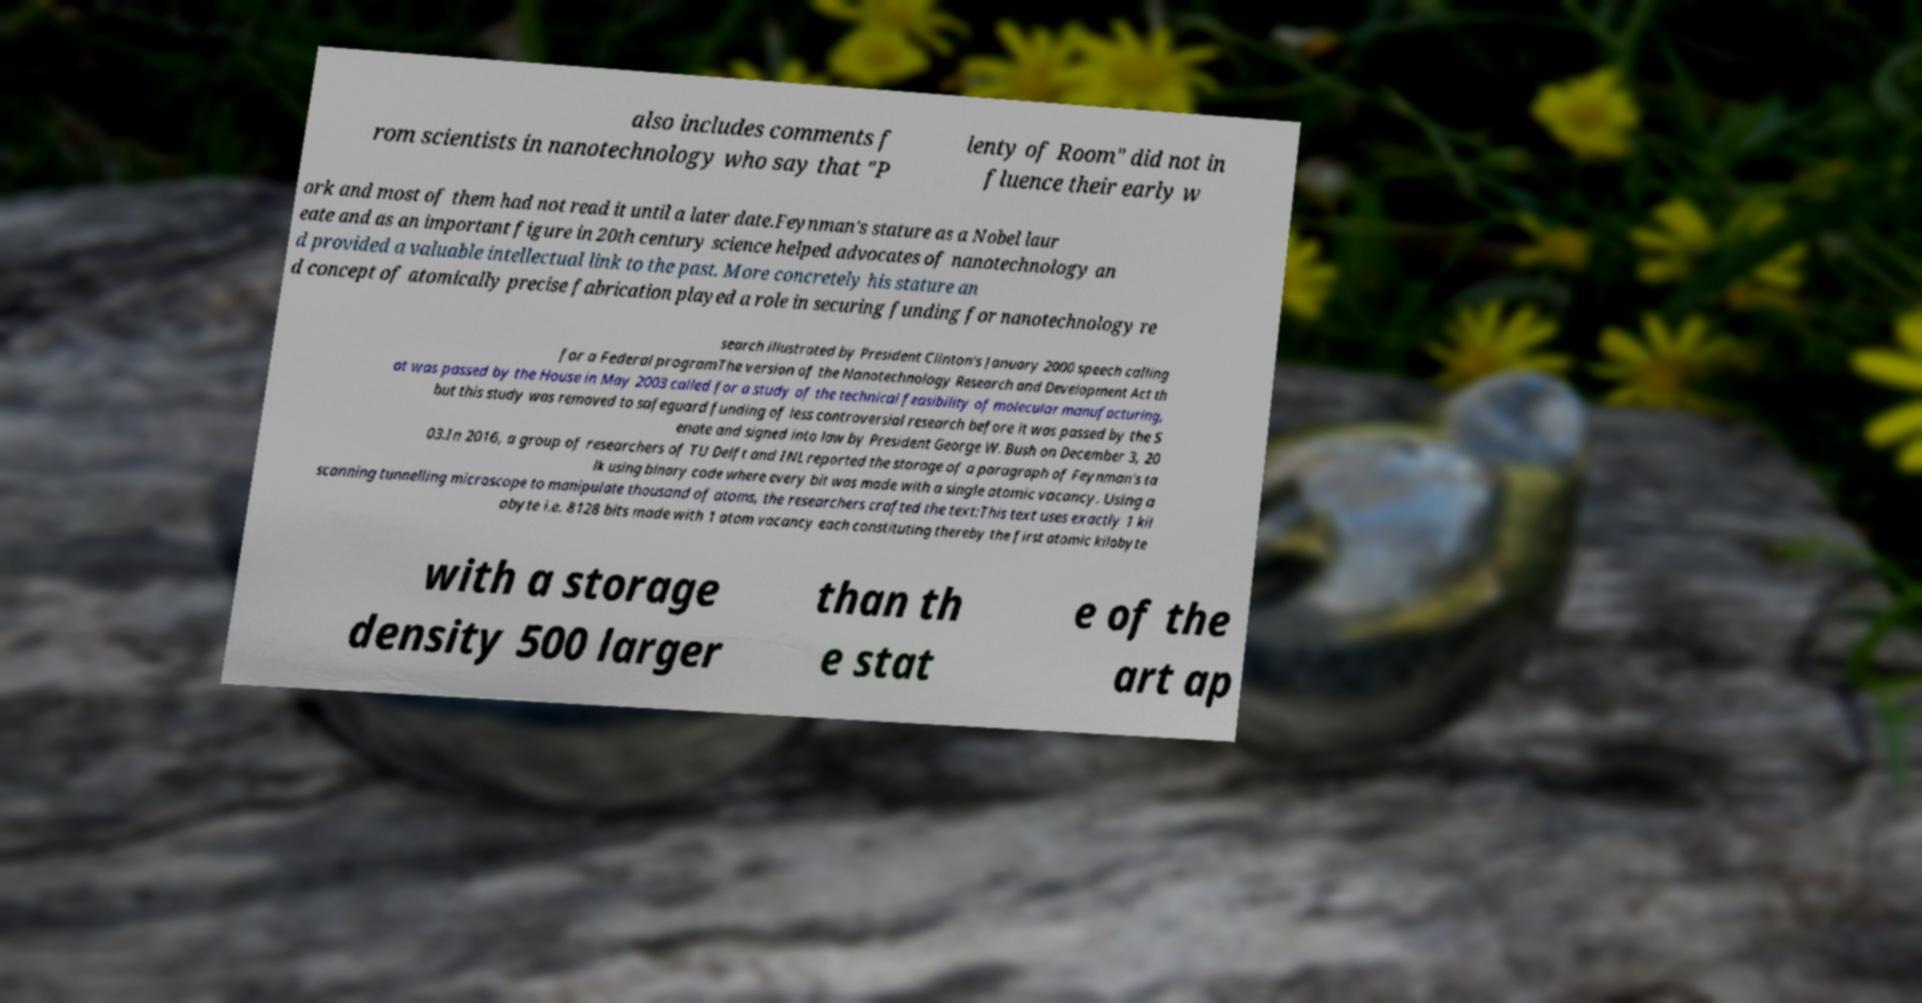For documentation purposes, I need the text within this image transcribed. Could you provide that? also includes comments f rom scientists in nanotechnology who say that "P lenty of Room" did not in fluence their early w ork and most of them had not read it until a later date.Feynman's stature as a Nobel laur eate and as an important figure in 20th century science helped advocates of nanotechnology an d provided a valuable intellectual link to the past. More concretely his stature an d concept of atomically precise fabrication played a role in securing funding for nanotechnology re search illustrated by President Clinton's January 2000 speech calling for a Federal programThe version of the Nanotechnology Research and Development Act th at was passed by the House in May 2003 called for a study of the technical feasibility of molecular manufacturing, but this study was removed to safeguard funding of less controversial research before it was passed by the S enate and signed into law by President George W. Bush on December 3, 20 03.In 2016, a group of researchers of TU Delft and INL reported the storage of a paragraph of Feynman's ta lk using binary code where every bit was made with a single atomic vacancy. Using a scanning tunnelling microscope to manipulate thousand of atoms, the researchers crafted the text:This text uses exactly 1 kil obyte i.e. 8128 bits made with 1 atom vacancy each constituting thereby the first atomic kilobyte with a storage density 500 larger than th e stat e of the art ap 